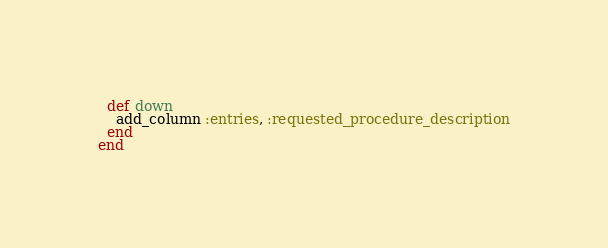<code> <loc_0><loc_0><loc_500><loc_500><_Ruby_>  def down
    add_column :entries, :requested_procedure_description
  end
end
</code> 